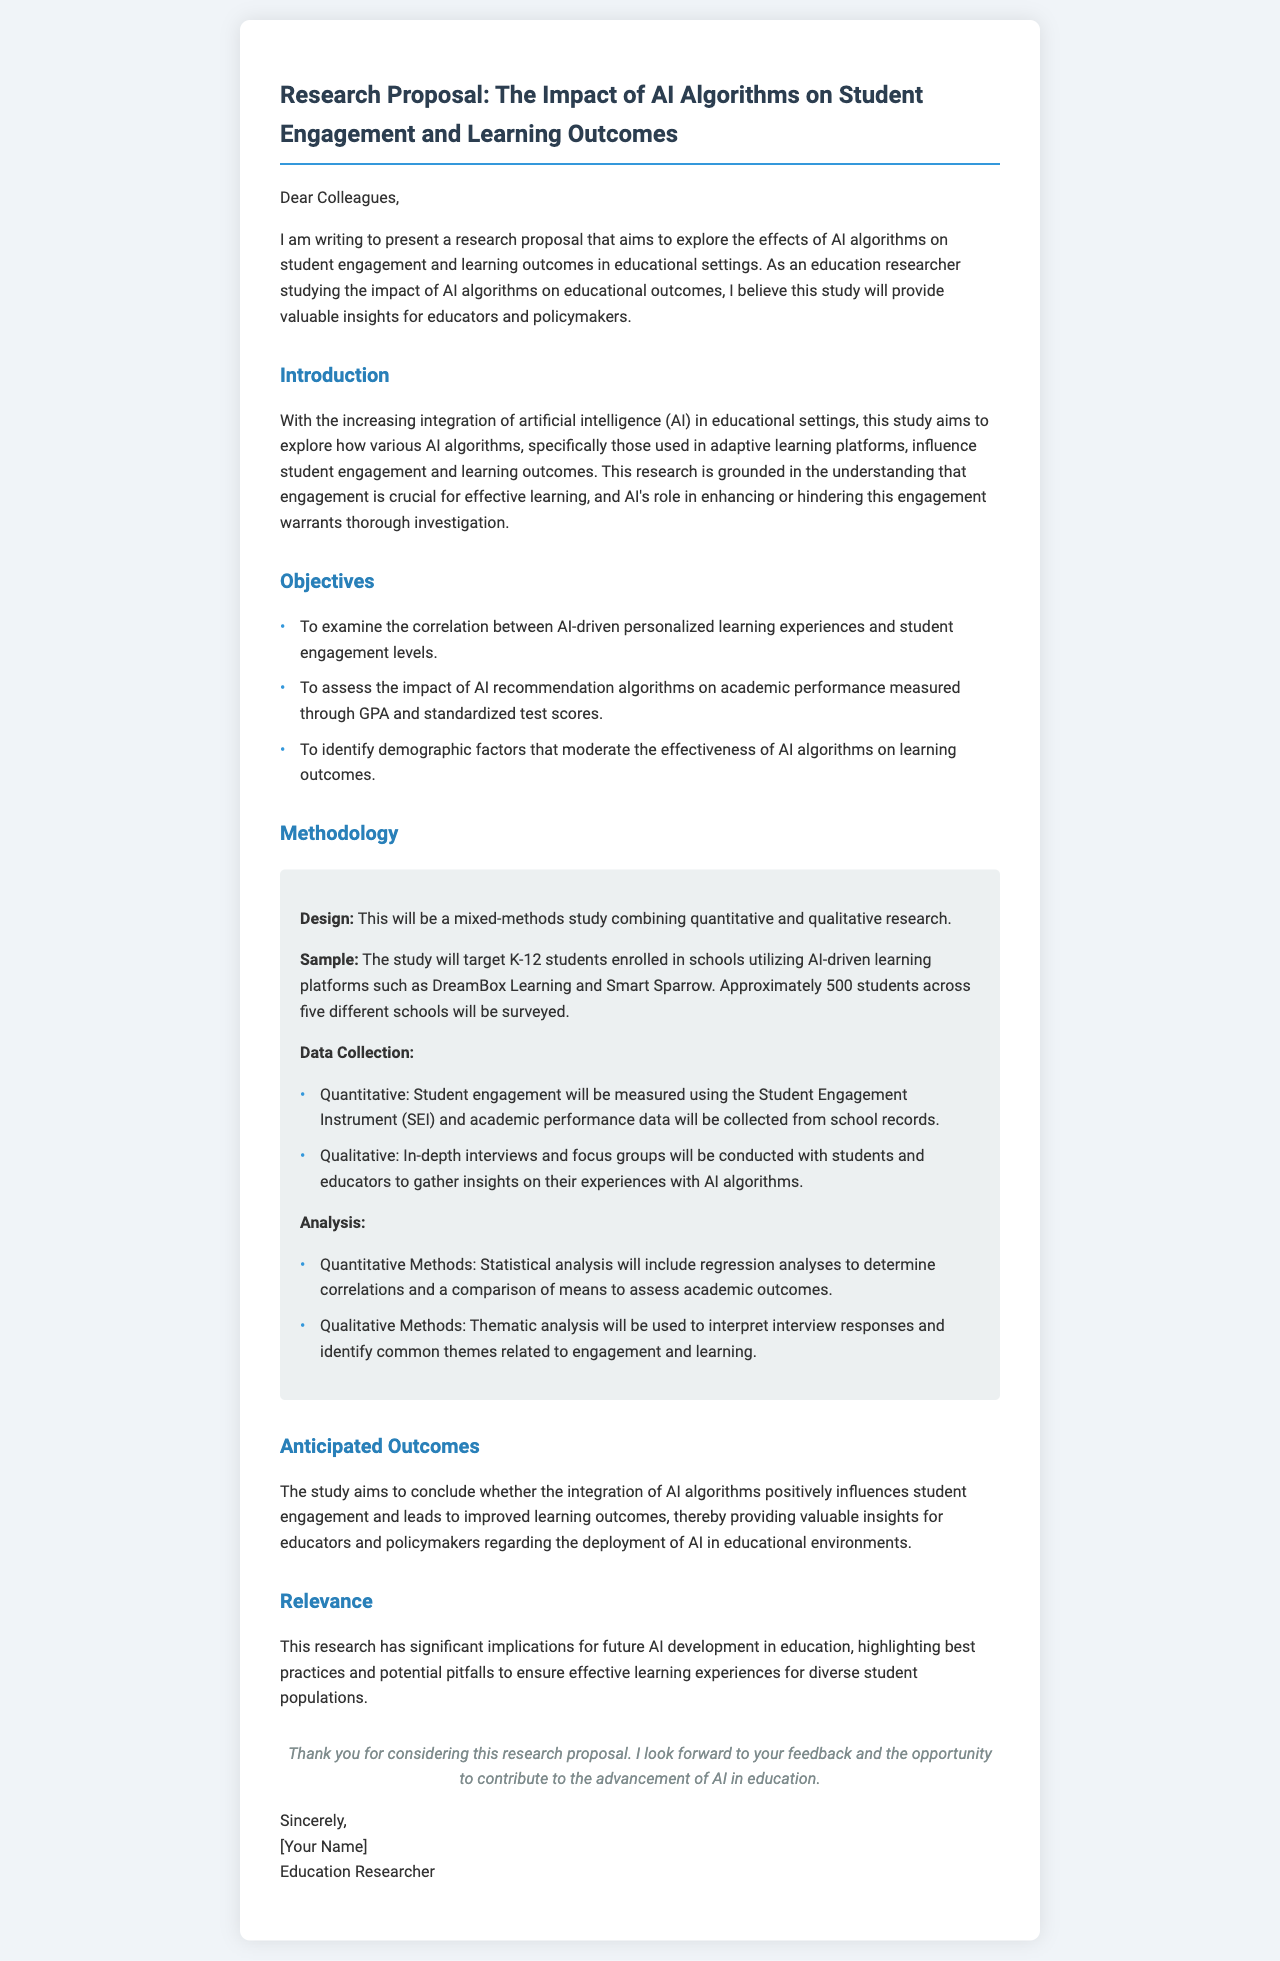What is the main objective of the study? The primary aim of the study is to explore the effects of AI algorithms on student engagement and learning outcomes.
Answer: Explore the effects of AI algorithms on student engagement and learning outcomes How many students will be surveyed in the study? The document specifies that approximately 500 students will be surveyed.
Answer: Approximately 500 students What instruments will be used to measure student engagement? The Student Engagement Instrument (SEI) is mentioned as the tool for measuring student engagement.
Answer: Student Engagement Instrument (SEI) What are the two types of data collected in the study? The study will collect quantitative and qualitative data.
Answer: Quantitative and qualitative Which AI-driven learning platforms are mentioned in the proposal? The document names DreamBox Learning and Smart Sparrow as the platforms of focus.
Answer: DreamBox Learning and Smart Sparrow What type of research design will be used in this study? A mixed-methods study combining quantitative and qualitative research is the chosen design.
Answer: Mixed-methods study What is the anticipated outcome of the study? The study aims to determine if AI algorithms positively influence student engagement and learning outcomes.
Answer: Determine if AI algorithms positively influence student engagement and learning outcomes What is highlighted as crucial for effective learning in the introduction? Engagement is noted as crucial for effective learning.
Answer: Engagement 